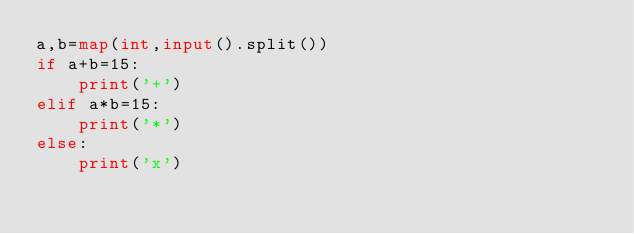<code> <loc_0><loc_0><loc_500><loc_500><_Python_>a,b=map(int,input().split())
if a+b=15:
    print('+')
elif a*b=15:
    print('*')
else:
    print('x')
</code> 